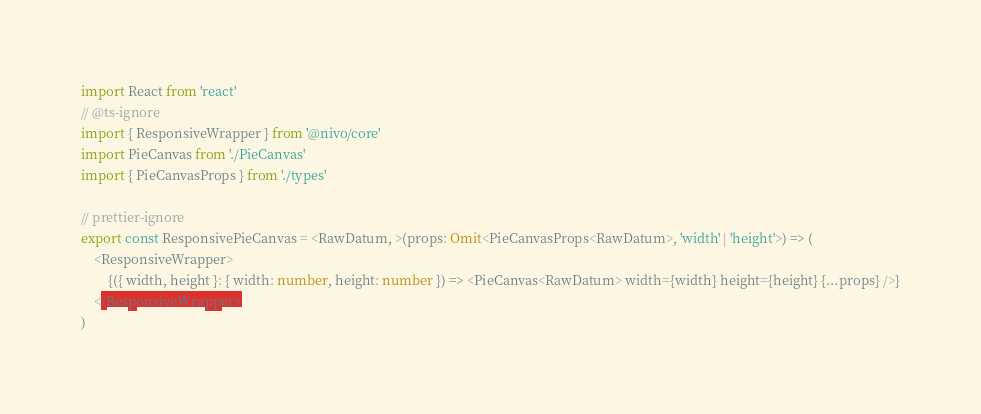<code> <loc_0><loc_0><loc_500><loc_500><_TypeScript_>import React from 'react'
// @ts-ignore
import { ResponsiveWrapper } from '@nivo/core'
import PieCanvas from './PieCanvas'
import { PieCanvasProps } from './types'

// prettier-ignore
export const ResponsivePieCanvas = <RawDatum, >(props: Omit<PieCanvasProps<RawDatum>, 'width' | 'height'>) => (
    <ResponsiveWrapper>
        {({ width, height }: { width: number, height: number }) => <PieCanvas<RawDatum> width={width} height={height} {...props} />}
    </ResponsiveWrapper>
)
</code> 